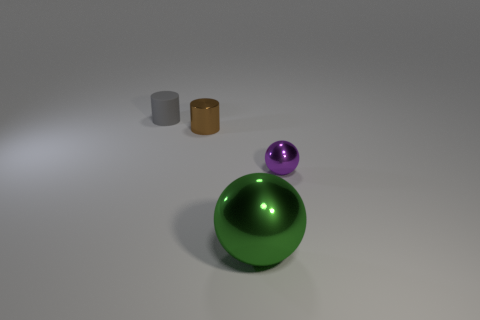Add 2 tiny red metallic things. How many objects exist? 6 Add 3 large green objects. How many large green objects exist? 4 Subtract 0 brown balls. How many objects are left? 4 Subtract all brown things. Subtract all big green metal spheres. How many objects are left? 2 Add 3 tiny spheres. How many tiny spheres are left? 4 